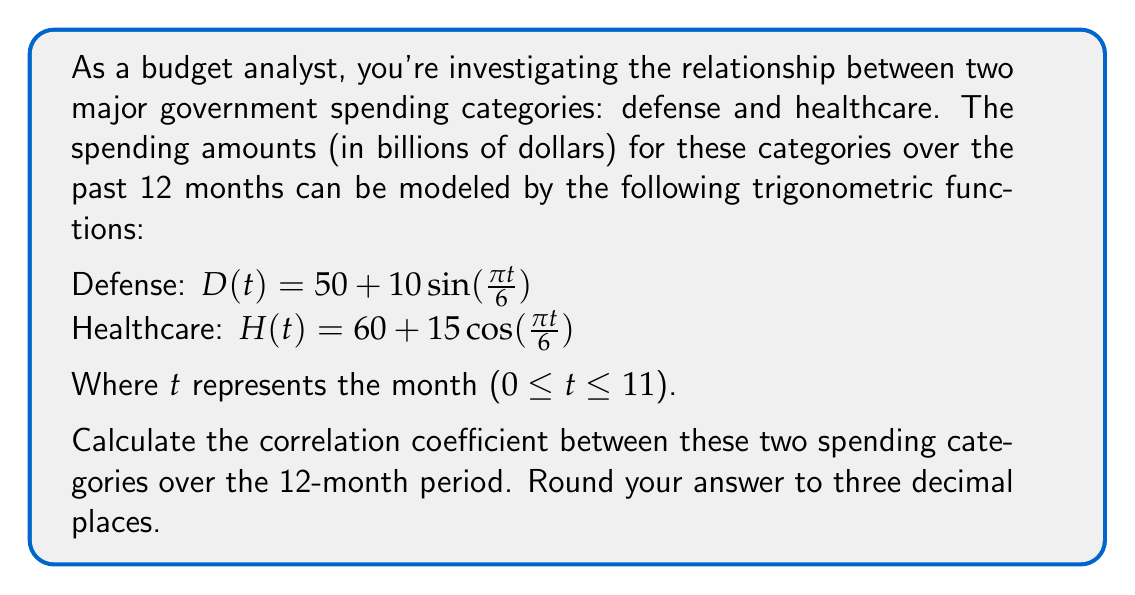Could you help me with this problem? To calculate the correlation coefficient between these two spending categories, we'll follow these steps:

1) First, we need to calculate the mean values for both categories:

   $\bar{D} = \frac{1}{12}\sum_{t=0}^{11} D(t)$
   $\bar{H} = \frac{1}{12}\sum_{t=0}^{11} H(t)$

   For D(t): $\bar{D} = 50$ (because the sine function averages to 0 over a full period)
   For H(t): $\bar{H} = 60$ (because the cosine function averages to 0 over a full period)

2) Next, we calculate the covariance:

   $Cov(D,H) = \frac{1}{12}\sum_{t=0}^{11} (D(t) - \bar{D})(H(t) - \bar{H})$

   $= \frac{1}{12}\sum_{t=0}^{11} (10\sin(\frac{\pi t}{6}))(15\cos(\frac{\pi t}{6}))$

   $= \frac{150}{12}\sum_{t=0}^{11} \sin(\frac{\pi t}{6})\cos(\frac{\pi t}{6})$

   $= \frac{150}{12} \cdot \frac{1}{2}\sum_{t=0}^{11} \sin(\frac{\pi t}{3})$ (using the trigonometric identity $2\sin A \cos A = \sin(2A)$)

   $= \frac{75}{12} \cdot 0 = 0$ (because $\sum_{t=0}^{11} \sin(\frac{\pi t}{3}) = 0$ over a full period)

3) Now we calculate the standard deviations:

   For D(t): $\sigma_D = \sqrt{\frac{1}{12}\sum_{t=0}^{11} (D(t) - \bar{D})^2} = \sqrt{\frac{1}{12}\sum_{t=0}^{11} (10\sin(\frac{\pi t}{6}))^2} = \frac{10}{\sqrt{2}}$

   For H(t): $\sigma_H = \sqrt{\frac{1}{12}\sum_{t=0}^{11} (H(t) - \bar{H})^2} = \sqrt{\frac{1}{12}\sum_{t=0}^{11} (15\cos(\frac{\pi t}{6}))^2} = \frac{15}{\sqrt{2}}$

4) Finally, we calculate the correlation coefficient:

   $r = \frac{Cov(D,H)}{\sigma_D \sigma_H} = \frac{0}{(\frac{10}{\sqrt{2}})(\frac{15}{\sqrt{2}})} = 0$

Therefore, the correlation coefficient is 0, indicating no linear correlation between the two spending categories over the 12-month period.
Answer: 0.000 